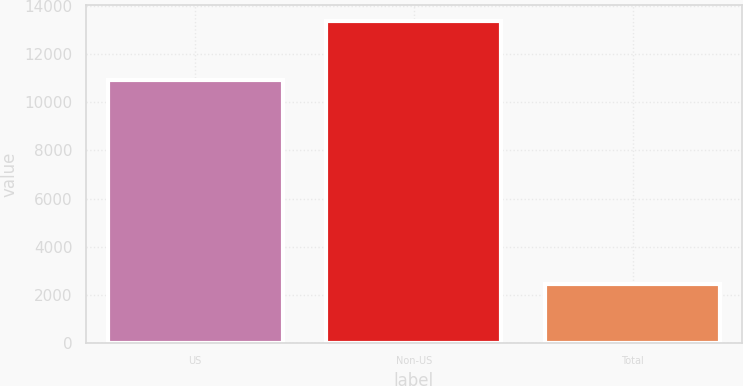Convert chart. <chart><loc_0><loc_0><loc_500><loc_500><bar_chart><fcel>US<fcel>Non-US<fcel>Total<nl><fcel>10919<fcel>13379<fcel>2460<nl></chart> 